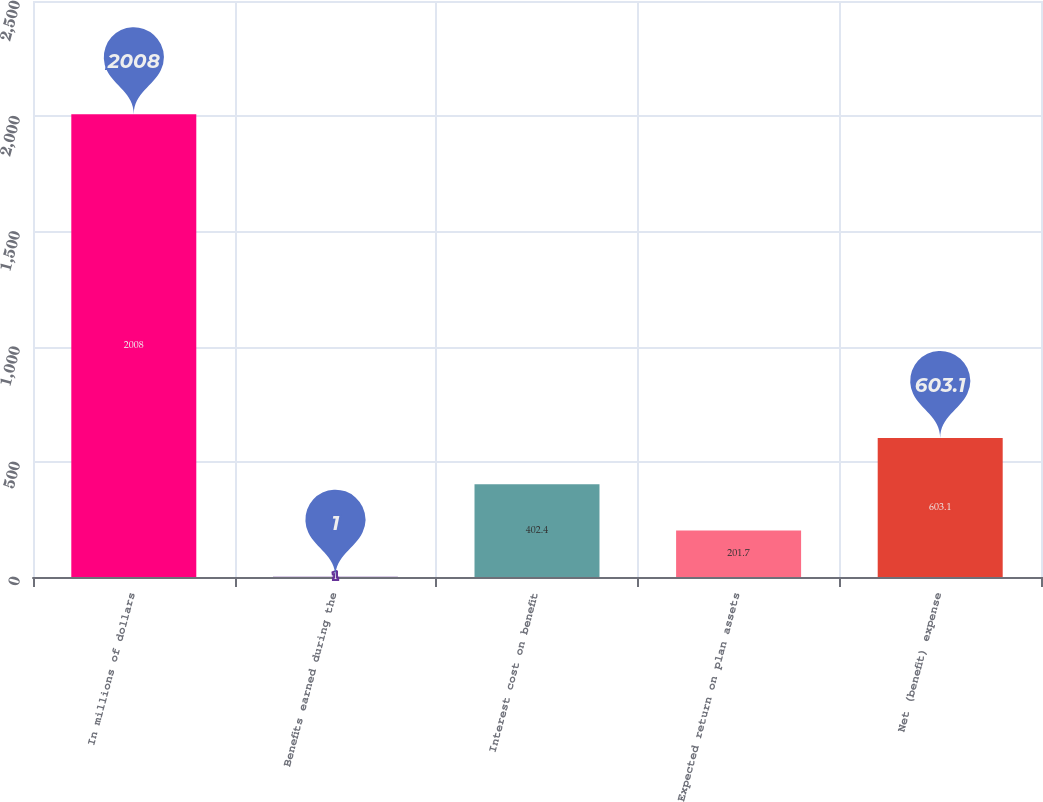Convert chart. <chart><loc_0><loc_0><loc_500><loc_500><bar_chart><fcel>In millions of dollars<fcel>Benefits earned during the<fcel>Interest cost on benefit<fcel>Expected return on plan assets<fcel>Net (benefit) expense<nl><fcel>2008<fcel>1<fcel>402.4<fcel>201.7<fcel>603.1<nl></chart> 